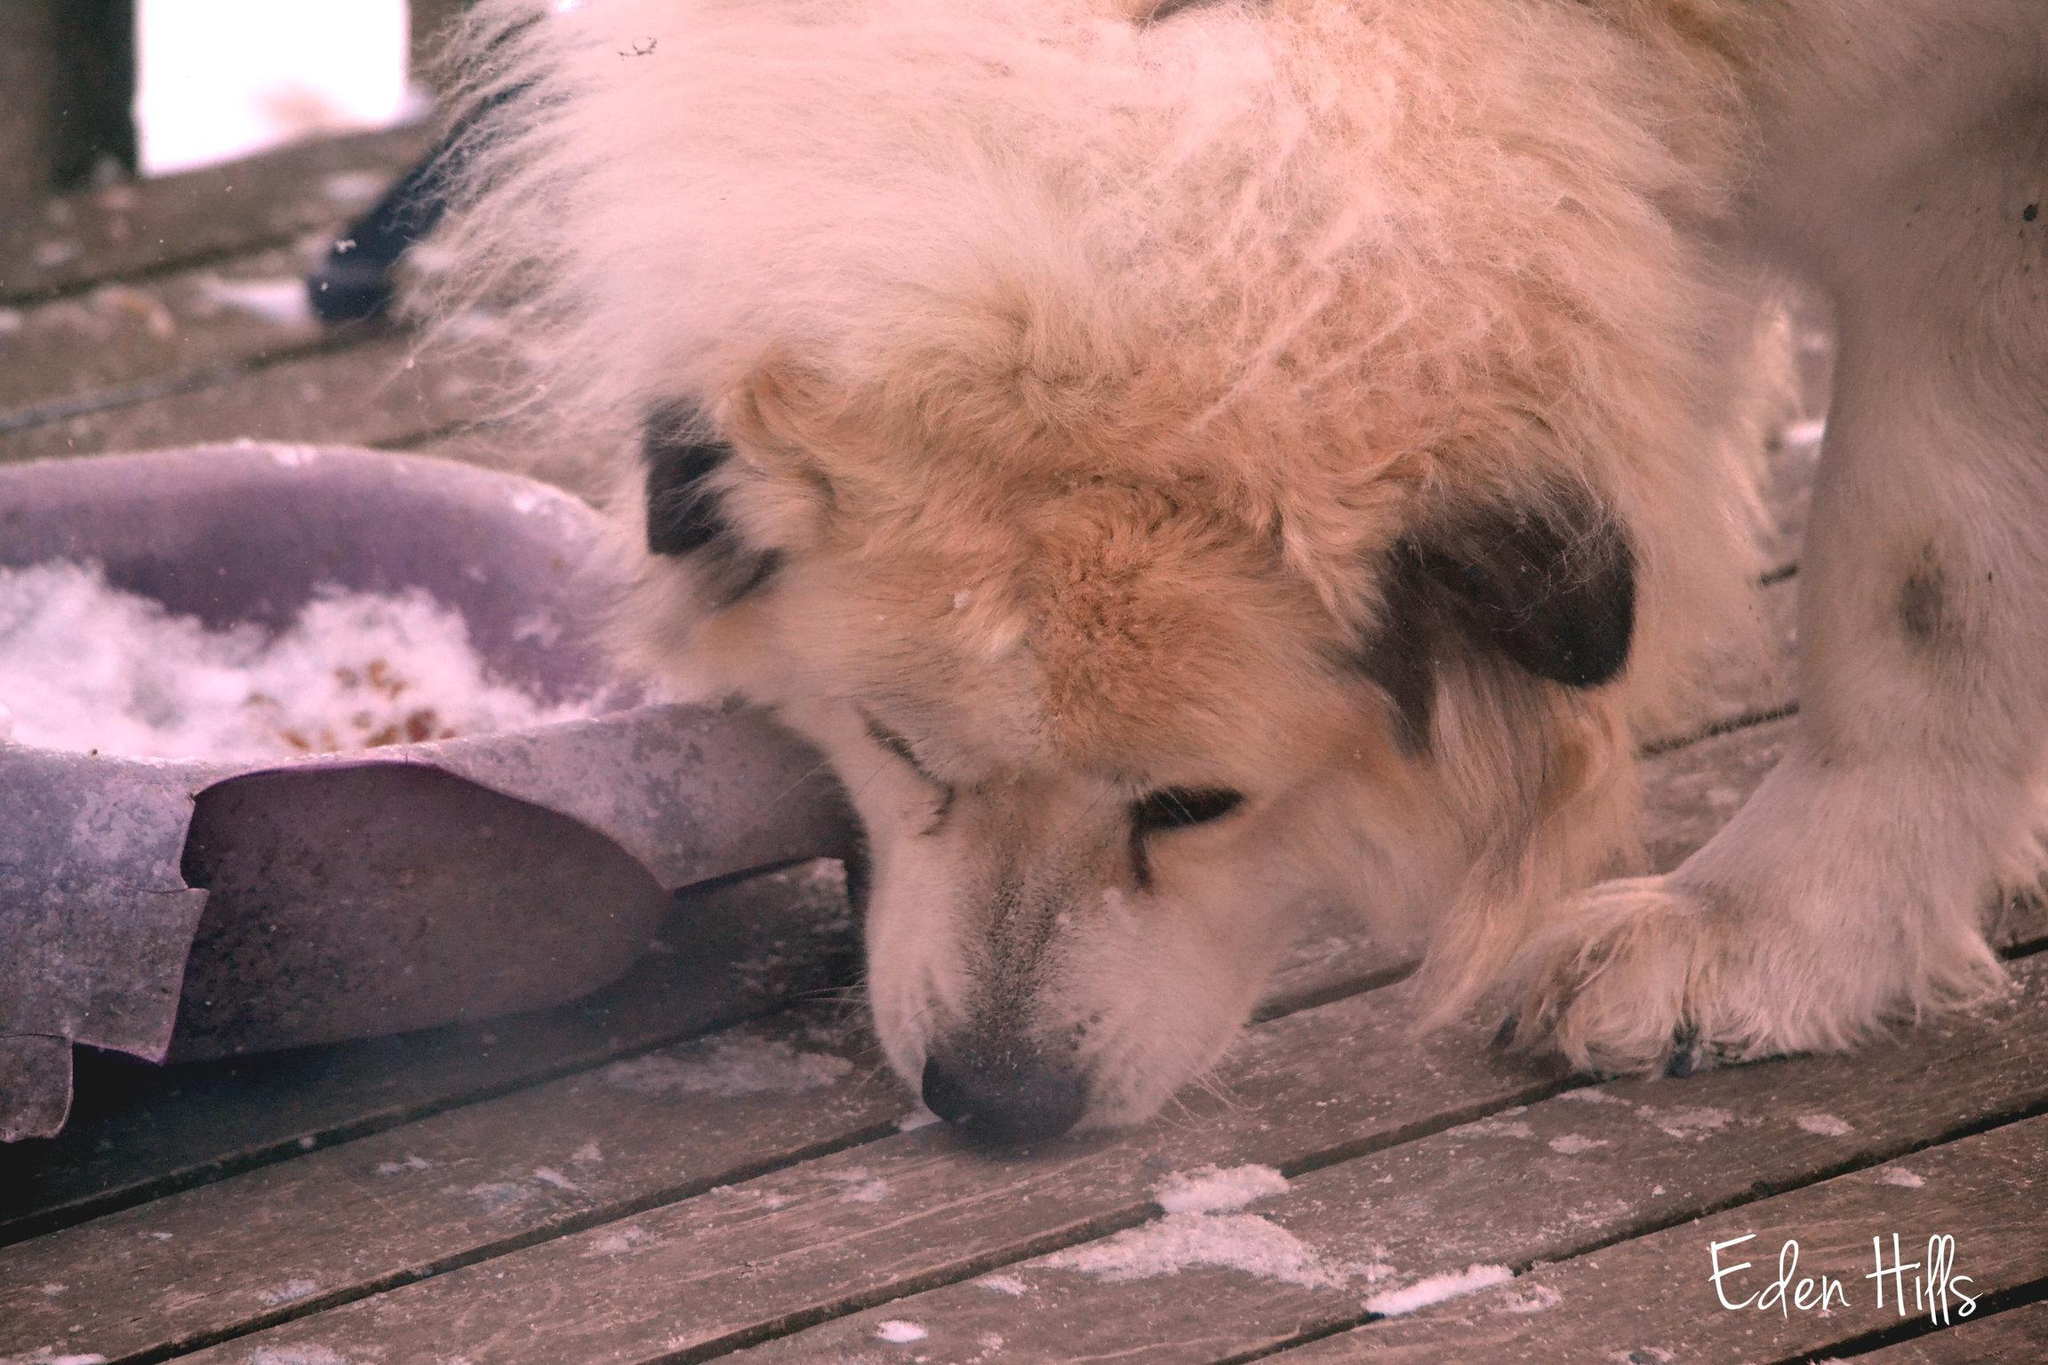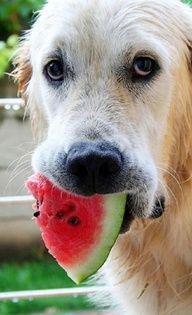The first image is the image on the left, the second image is the image on the right. Examine the images to the left and right. Is the description "An image shows more than one animal with its face in a round bowl, and at least one of the animals is a white dog." accurate? Answer yes or no. No. The first image is the image on the left, the second image is the image on the right. Examine the images to the left and right. Is the description "The dog in the right image has food in its mouth." accurate? Answer yes or no. Yes. 